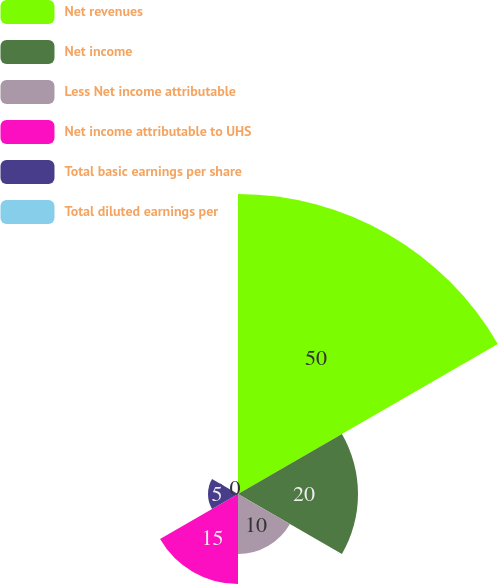<chart> <loc_0><loc_0><loc_500><loc_500><pie_chart><fcel>Net revenues<fcel>Net income<fcel>Less Net income attributable<fcel>Net income attributable to UHS<fcel>Total basic earnings per share<fcel>Total diluted earnings per<nl><fcel>50.0%<fcel>20.0%<fcel>10.0%<fcel>15.0%<fcel>5.0%<fcel>0.0%<nl></chart> 